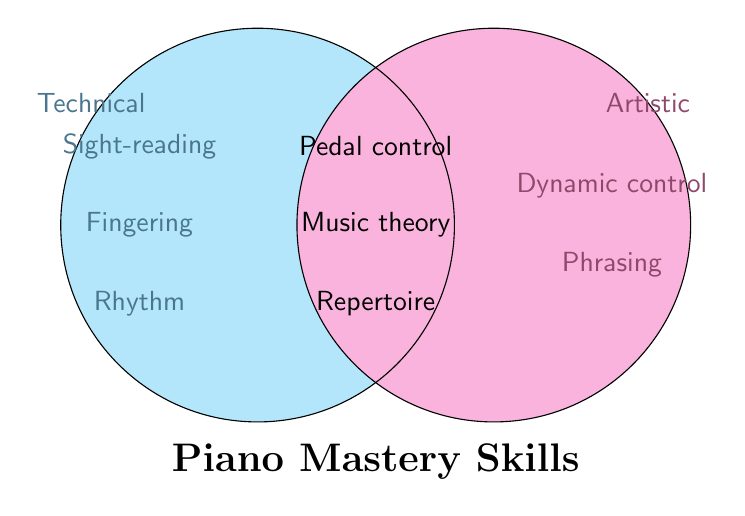What are the categories in the Venn Diagram? The categories are labeled in the two circles. The left circle is "Technical" and the right circle is "Artistic."
Answer: Technical and Artistic Which skills are common to both categories? The skills common to both categories are located in the overlapping section of the circles. They include Pedal control, Music theory knowledge, and Repertoire familiarity.
Answer: Pedal control, Music theory knowledge, Repertoire familiarity What skill is found in the Technical category but not in the Artistic category? The skills in the Technical category are placed in the left circle without overlapping the right circle. These include Sight-reading, Fingering technique, and Rhythm mastery.
Answer: Sight-reading, Fingering technique, Rhythm mastery Which skills are unique to the Artistic category? The skills unique to the Artistic category are in the right circle without overlapping the left circle. These include Dynamic control and Phrasing.
Answer: Dynamic control, Phrasing How many skills are necessary for Technical mastery only? Count the number of skills in the Technical circle that do not overlap with the Artistic circle. These are Sight-reading, Fingering technique, and Rhythm mastery, making it a total of three.
Answer: 3 How many skills in total are necessary for both Technical and Artistic mastery? Sum the skills in each category. Technical has 3 unique skills, Artistic has 2 unique skills, and both categories share 3 skills. The total is 3 + 2 + 3.
Answer: 8 Which skill requires mastery of both technical and artistic aspects? The skills requiring both aspects are located in the overlapping section. They are Pedal control, Music theory knowledge, and Repertoire familiarity.
Answer: Pedal control, Music theory knowledge, Repertoire familiarity Add up the total number of skills listed in the diagram. Count all the skills, considering the overlap only once: Sight-reading, Fingering technique, Rhythm mastery (3 Technical), Dynamic control, Phrasing (2 Artistic), and Pedal control, Music theory knowledge, Repertoire familiarity (3 both). In total: 3 + 2 + 3.
Answer: 8 Which category has skills related to controlling the dynamics of playing? The Artistic category has skills related to controlling the dynamics. These skills are Dynamic control and Pedal control.
Answer: Artistic What proportion of the skills are shared between both categories? There are a total of 8 skills in the diagram, and 3 of them are shared between both categories. The proportion is calculated as 3/8.
Answer: 3/8 